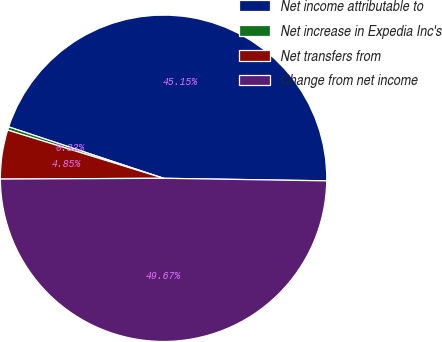<chart> <loc_0><loc_0><loc_500><loc_500><pie_chart><fcel>Net income attributable to<fcel>Net increase in Expedia Inc's<fcel>Net transfers from<fcel>Change from net income<nl><fcel>45.15%<fcel>0.33%<fcel>4.85%<fcel>49.67%<nl></chart> 